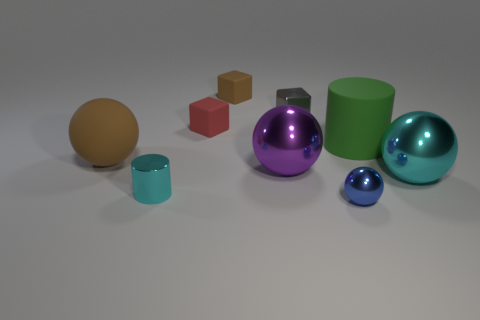Subtract all small matte cubes. How many cubes are left? 1 Subtract all purple spheres. How many spheres are left? 3 Subtract all red balls. Subtract all blue cubes. How many balls are left? 4 Add 1 large cyan balls. How many objects exist? 10 Subtract all spheres. How many objects are left? 5 Subtract 0 blue blocks. How many objects are left? 9 Subtract all cyan cylinders. Subtract all rubber spheres. How many objects are left? 7 Add 4 small blue spheres. How many small blue spheres are left? 5 Add 2 blocks. How many blocks exist? 5 